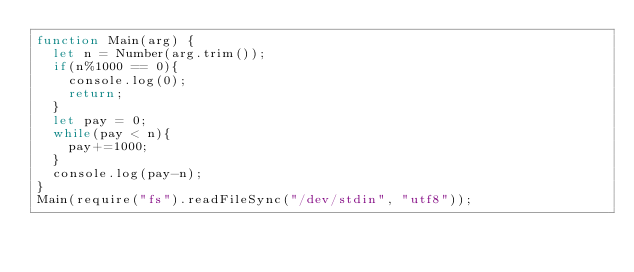<code> <loc_0><loc_0><loc_500><loc_500><_JavaScript_>function Main(arg) {
  let n = Number(arg.trim());
  if(n%1000 == 0){
    console.log(0);
    return;
  }
  let pay = 0;
  while(pay < n){
    pay+=1000;
  }
  console.log(pay-n);
}
Main(require("fs").readFileSync("/dev/stdin", "utf8"));</code> 